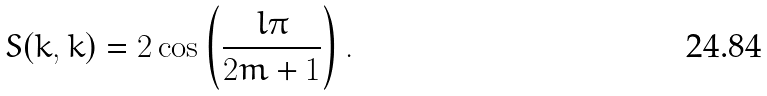<formula> <loc_0><loc_0><loc_500><loc_500>S ( k , k ) = 2 \cos \left ( \frac { l \pi } { 2 m + 1 } \right ) .</formula> 